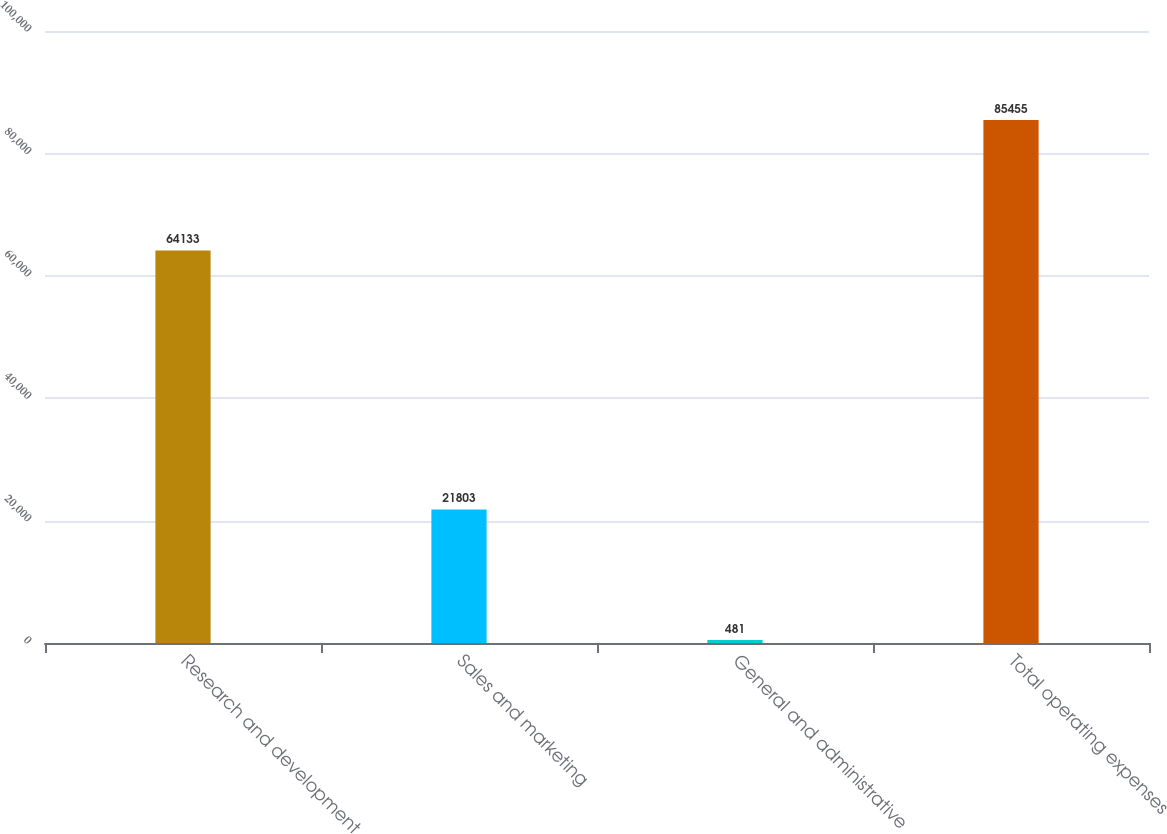<chart> <loc_0><loc_0><loc_500><loc_500><bar_chart><fcel>Research and development<fcel>Sales and marketing<fcel>General and administrative<fcel>Total operating expenses<nl><fcel>64133<fcel>21803<fcel>481<fcel>85455<nl></chart> 